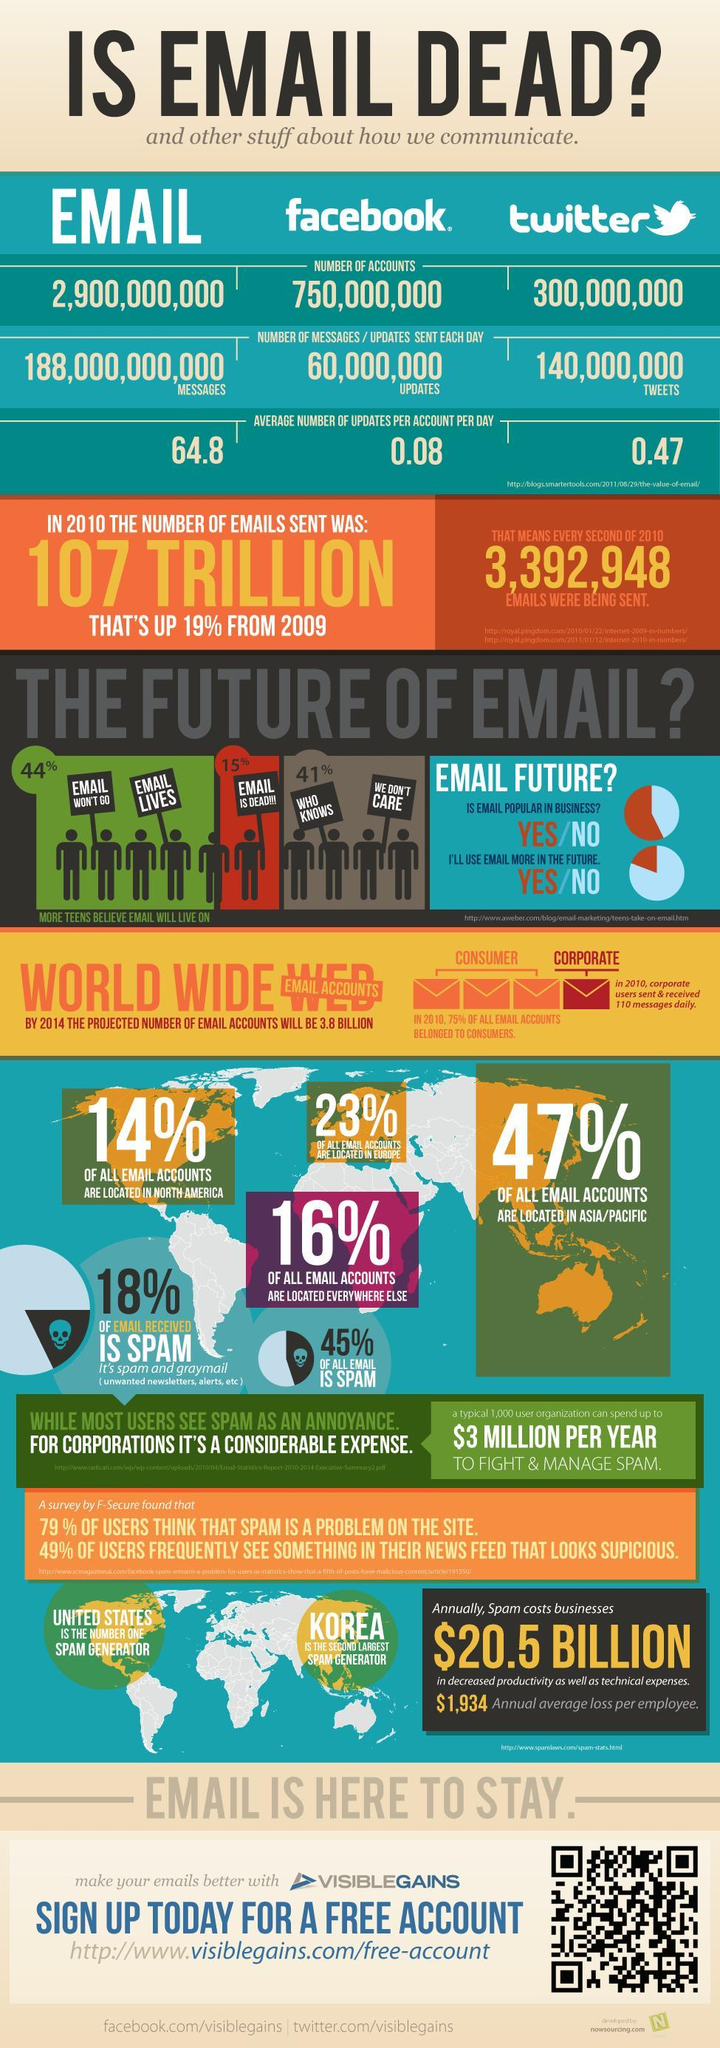What percentage of teens believe that emails still lives?
Answer the question with a short phrase. 44% What percentage of all emails are spam in the world? 45% What percentage of all emails accounts are located in Europe? 23% What is the average number of updates sent per email account per day? 64.8 How many facebook updates were sent each day worldwide? 60,000,000 What percentage of teens believe that emails are dead? 15% What is the number of twitter accounts worldwide? 300,000,000 What percentage of teens don't care about emails? 41% 